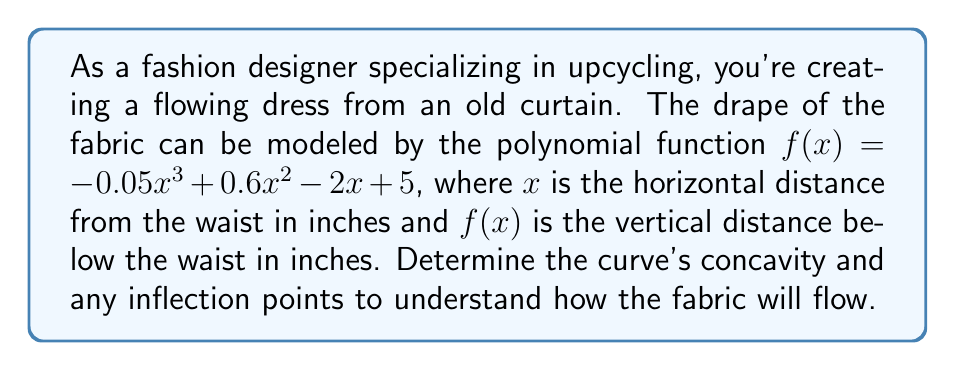Teach me how to tackle this problem. To determine the curve's concavity and inflection points, we need to analyze the second derivative of the function.

Step 1: Find the first derivative.
$f'(x) = -0.15x^2 + 1.2x - 2$

Step 2: Find the second derivative.
$f''(x) = -0.3x + 1.2$

Step 3: Analyze the second derivative:
- When $f''(x) > 0$, the curve is concave up.
- When $f''(x) < 0$, the curve is concave down.
- When $f''(x) = 0$, there's a potential inflection point.

Step 4: Solve for $f''(x) = 0$:
$-0.3x + 1.2 = 0$
$-0.3x = -1.2$
$x = 4$

Step 5: Evaluate concavity:
- For $x < 4$, $f''(x) > 0$, so the curve is concave up.
- For $x > 4$, $f''(x) < 0$, so the curve is concave down.

Step 6: Confirm the inflection point:
Since $f''(x)$ changes sign at $x = 4$, this point is indeed an inflection point.

The inflection point occurs at $(4, f(4))$:
$f(4) = -0.05(4^3) + 0.6(4^2) - 2(4) + 5 = -3.2$ inches

Therefore, the inflection point is at (4, -3.2).
Answer: Concave up for $x < 4$, concave down for $x > 4$, inflection point at (4, -3.2) 